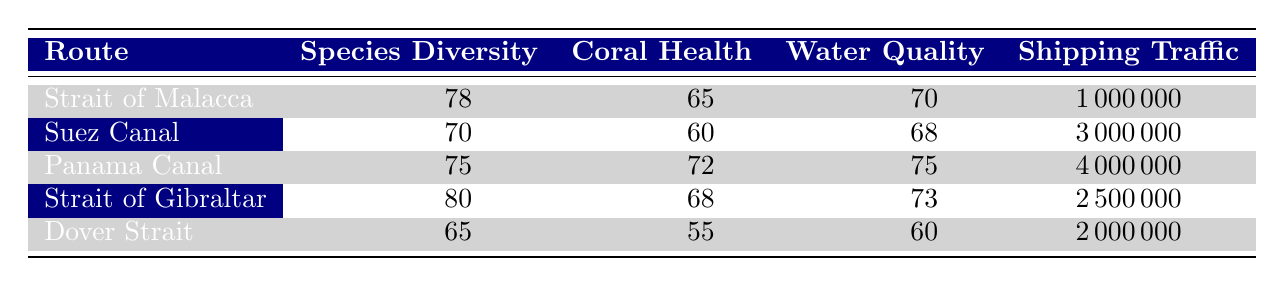What is the species diversity index for the Suez Canal? The species diversity index for the Suez Canal is printed in the table under the "Species Diversity" column for that route. It is 70.
Answer: 70 What is the coral health index of the Panama Canal? The coral health index for the Panama Canal can be found in the "Coral Health" column in the table. It shows a value of 72.
Answer: 72 Which route has the highest water quality index? By comparing the values in the "Water Quality" column, the highest value is for the Panama Canal, which has a water quality index of 75.
Answer: Panama Canal Is the shipping traffic volume for the Dover Strait greater than for the Strait of Malacca? We can compare the shipping traffic volumes: Dover Strait has 2,000,000 while Strait of Malacca has 1,000,000. Since 2,000,000 is greater than 1,000,000, the statement is true.
Answer: Yes What is the average coral health index of the routes presented in the table? To calculate the average, sum all the coral health indices (65 + 60 + 72 + 68 + 55) = 320 and then divide by the number of routes (5). So, 320/5 = 64.
Answer: 64 Which route has the lowest marine species diversity index? The lowest value in the "Species Diversity" column can be found for the Dover Strait, which has a value of 65.
Answer: Dover Strait Is the shipping traffic volume for the Suez Canal less than that of the Panama Canal? By looking at the "Shipping Traffic" column, the Suez Canal has 3,000,000 while the Panama Canal has 4,000,000. Since 3,000,000 is less than 4,000,000, the statement is true.
Answer: Yes If you add the marine species diversity indices of the Strait of Malacca and the Strait of Gibraltar, what is the result? The marine species diversity index for the Strait of Malacca is 78, and for the Strait of Gibraltar, it is 80. Adding these two gives 78 + 80 = 158.
Answer: 158 What is the water quality index difference between the Suez Canal and the Dover Strait? The water quality index of the Suez Canal is 68, and for the Dover Strait, it is 60. The difference is 68 - 60 = 8.
Answer: 8 